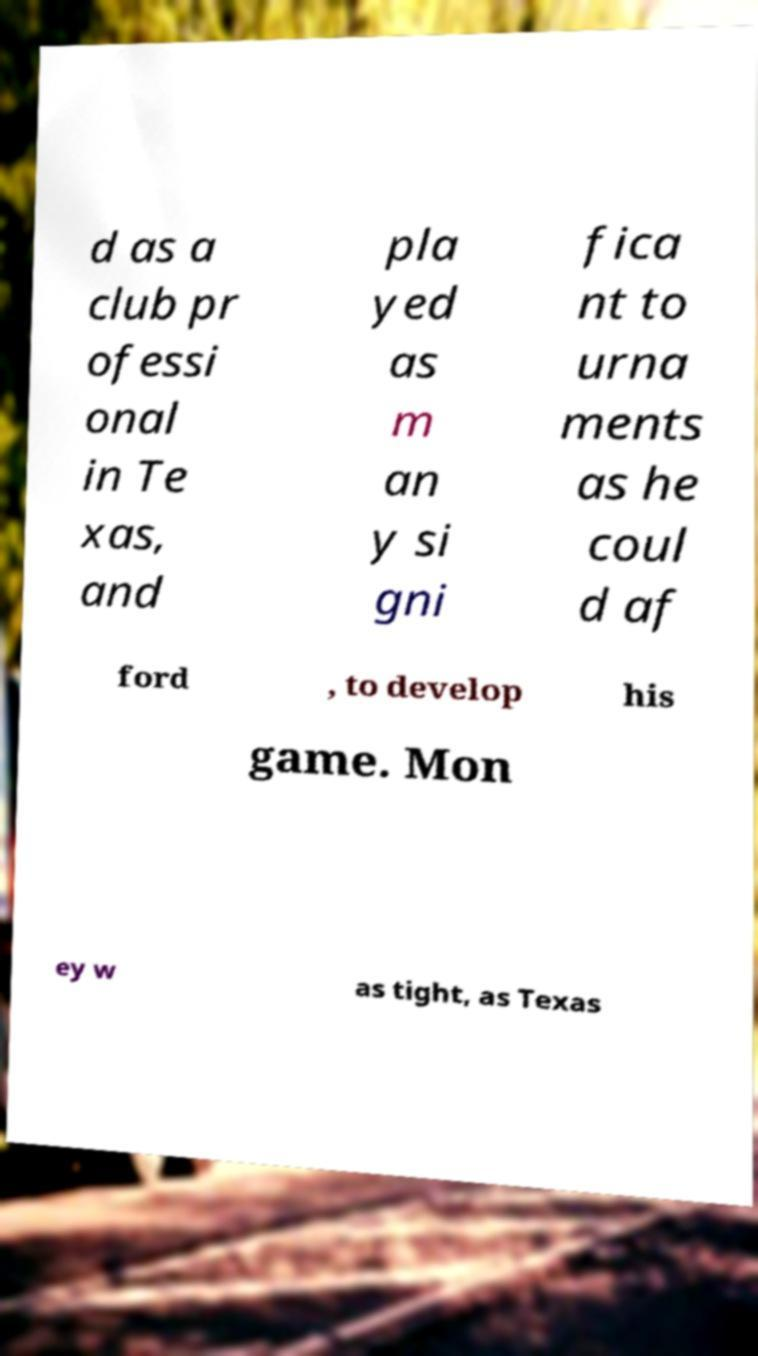Can you accurately transcribe the text from the provided image for me? d as a club pr ofessi onal in Te xas, and pla yed as m an y si gni fica nt to urna ments as he coul d af ford , to develop his game. Mon ey w as tight, as Texas 